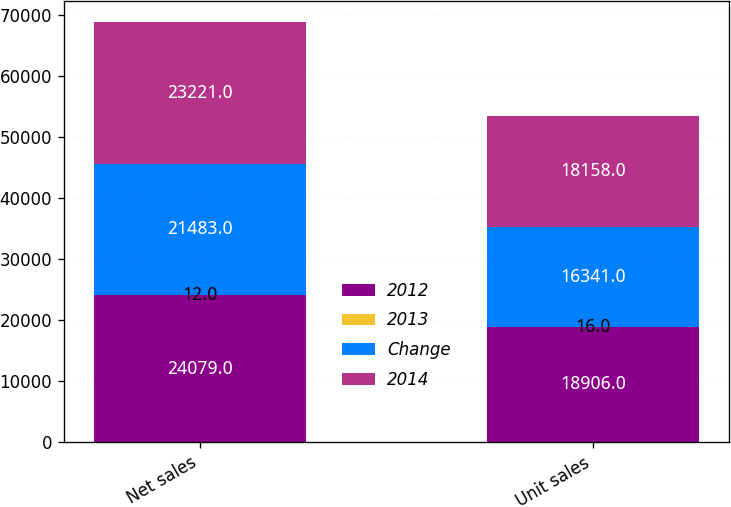<chart> <loc_0><loc_0><loc_500><loc_500><stacked_bar_chart><ecel><fcel>Net sales<fcel>Unit sales<nl><fcel>2012<fcel>24079<fcel>18906<nl><fcel>2013<fcel>12<fcel>16<nl><fcel>Change<fcel>21483<fcel>16341<nl><fcel>2014<fcel>23221<fcel>18158<nl></chart> 